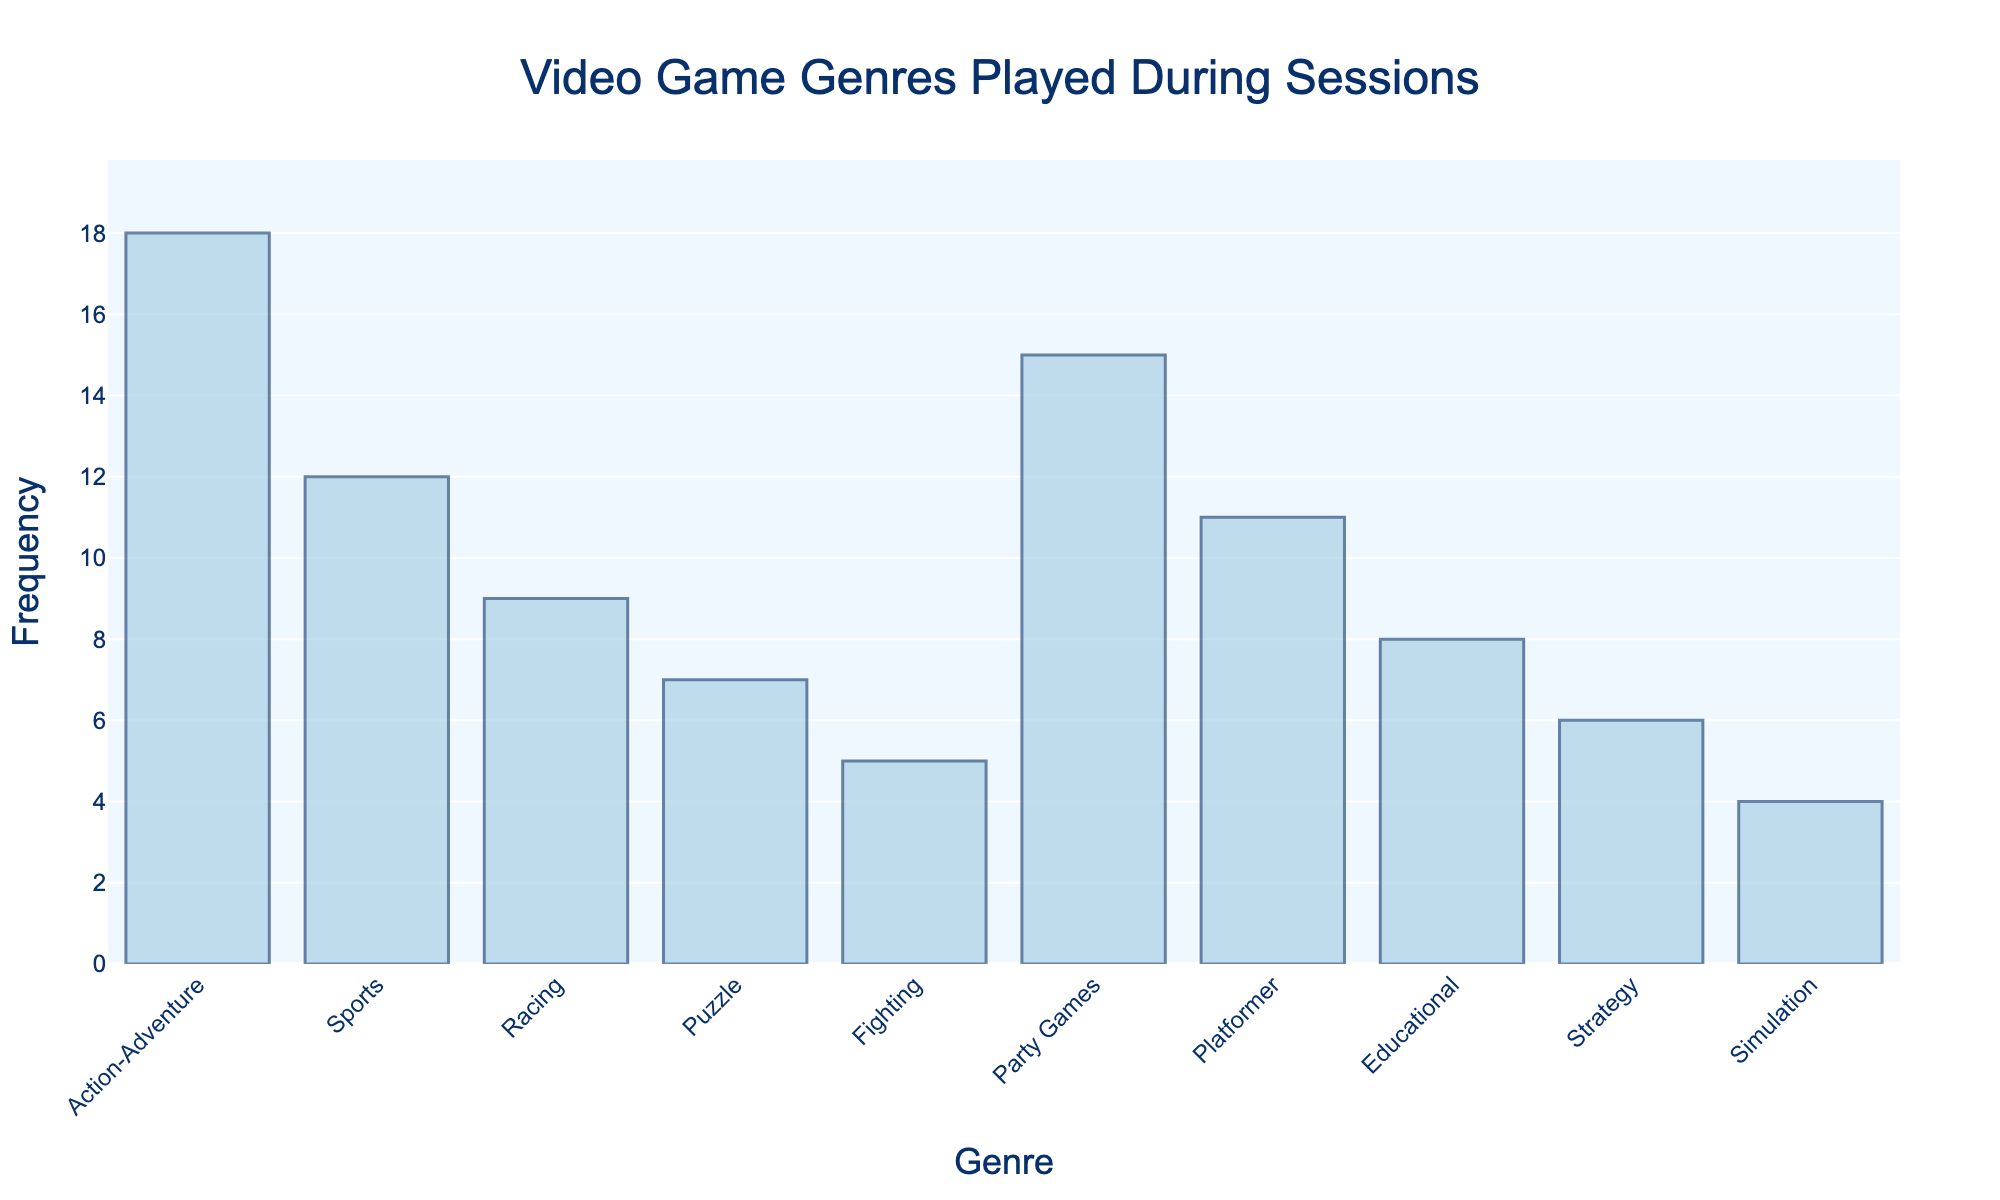What is the title of the figure? The title of the figure is positioned at the top and is centered. It provides a summary of what the figure represents. In this case, it says "Video Game Genres Played During Sessions".
Answer: Video Game Genres Played During Sessions What is the genre with the highest frequency? To find the genre with the highest frequency, look for the tallest bar in the histogram. The tallest bar corresponds to "Action-Adventure" with a frequency of 18.
Answer: Action-Adventure How many genres have a frequency of more than 10? By analyzing the bars, you can see "Action-Adventure" (18), "Sports" (12), "Party Games" (15), and "Platformer" (11) each have frequencies greater than 10. This makes a total of 4 genres.
Answer: 4 What's the total frequency of genres that have fewer than 10 plays? Identify the genres with frequencies less than 10: "Racing" (9), "Puzzle" (7), "Fighting" (5), "Educational" (8), "Strategy" (6), "Simulation" (4). Sum these values: 9 + 7 + 5 + 8 + 6 + 4 = 39.
Answer: 39 Which genre has the lowest frequency, and what is it? The genre with the lowest frequency is represented by the shortest bar. The shortest bar corresponds to "Simulation" with a frequency of 4.
Answer: Simulation, 4 How does the frequency of "Party Games" compare to "Educational"? Compare the heights of the bars for "Party Games" and "Educational". "Party Games" has a frequency of 15, and "Educational" has a frequency of 8. Since 15 is greater than 8, "Party Games" is more frequent.
Answer: Party Games is more frequent What is the combined frequency of "Sports" and "Platformer"? Look at the individual frequencies for "Sports" (12) and "Platformer" (11), then add them together: 12 + 11 = 23.
Answer: 23 What's the average frequency of all the genres played? Sum the frequencies of all the genres and then divide by the number of genres. Frequencies are: 18, 12, 9, 7, 5, 15, 11, 8, 6, 4. Total: 18 + 12 + 9 + 7 + 5 + 15 + 11 + 8 + 6 + 4 = 95. There are 10 genres. Average frequency = 95 / 10 = 9.5
Answer: 9.5 Which genre has the second highest frequency? Identify the genre with the second tallest bar. After "Action-Adventure" (18), the next tallest bar corresponds to "Party Games" with a frequency of 15.
Answer: Party Games List all genres with a frequency equal to or greater than 10 in descending order of frequency. The genres with frequencies equal to or above 10 are "Action-Adventure" (18), "Party Games" (15), "Sports" (12), and "Platformer" (11). In descending order: Action-Adventure, Party Games, Sports, Platformer.
Answer: Action-Adventure, Party Games, Sports, Platformer 